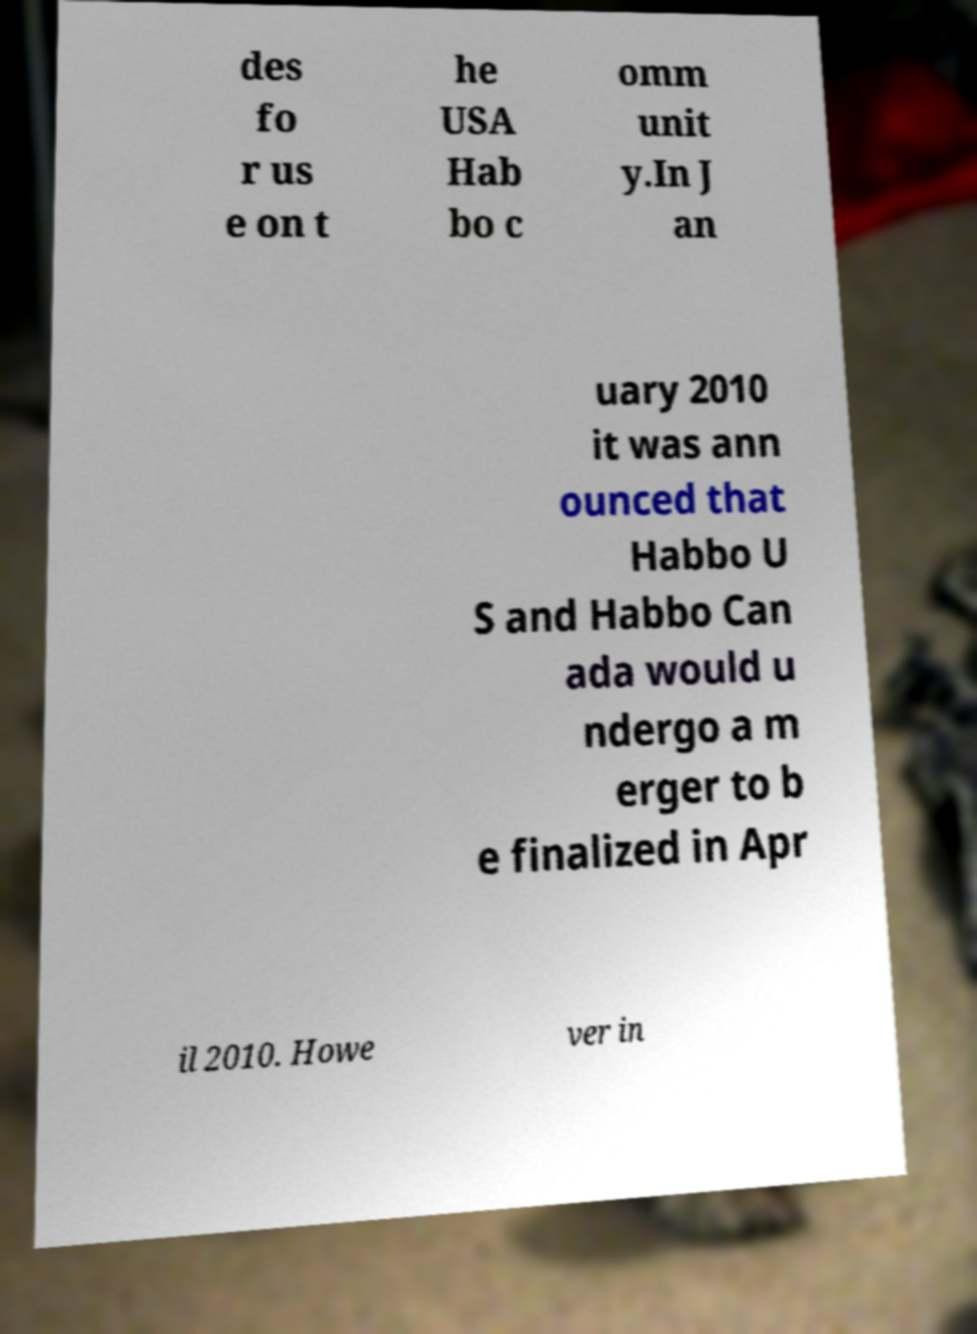Could you extract and type out the text from this image? des fo r us e on t he USA Hab bo c omm unit y.In J an uary 2010 it was ann ounced that Habbo U S and Habbo Can ada would u ndergo a m erger to b e finalized in Apr il 2010. Howe ver in 